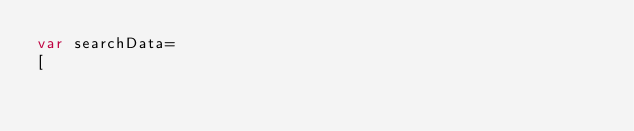<code> <loc_0><loc_0><loc_500><loc_500><_JavaScript_>var searchData=
[</code> 